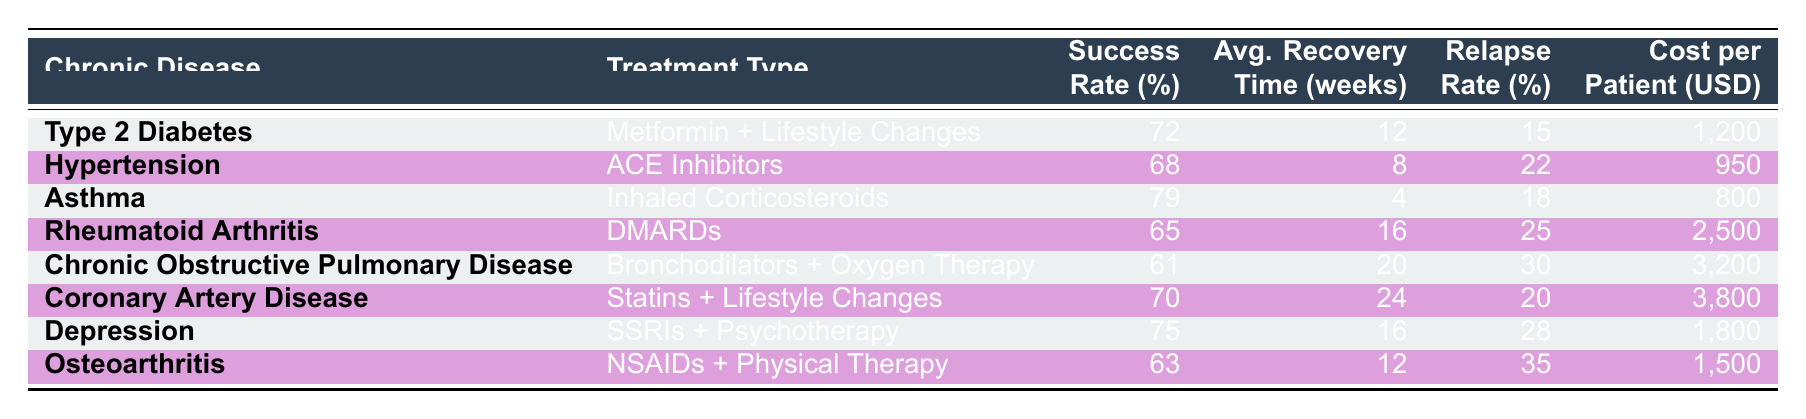What is the success rate for treating Asthma? According to the table, the success rate for treating Asthma with Inhaled Corticosteroids is listed directly as 79%.
Answer: 79% Which treatment has the highest relapse rate? The treatment with the highest relapse rate is Osteoarthritis, which has a relapse rate of 35%.
Answer: 35% What is the average recovery time for Chronic Obstructive Pulmonary Disease? The average recovery time for Chronic Obstructive Pulmonary Disease, treated with Bronchodilators and Oxygen Therapy, is 20 weeks.
Answer: 20 weeks Is the success rate for Type 2 Diabetes higher than that for Hypertension? Yes, the success rate for Type 2 Diabetes at 72% is higher than the success rate for Hypertension, which is 68%.
Answer: Yes What is the total cost per patient for treating both Depression and Osteoarthritis? To find the total cost, we add the cost for treating Depression at $1,800 and Osteoarthritis at $1,500: 1,800 + 1,500 = 3,300.
Answer: 3,300 What is the average success rate for all the treatments listed? To find the average success rate, sum all the success rates (72 + 68 + 79 + 65 + 61 + 70 + 75 + 63 = 563) and divide by the number of treatments (8). The average success rate is 563/8 = 70.375, which rounds to 70%.
Answer: 70.38% Does any treatment have a success rate below 65%? Yes, the treatment for Chronic Obstructive Pulmonary Disease has a success rate of 61%, which is below 65%.
Answer: Yes Which treatment option has the shortest average recovery time? The treatment with the shortest average recovery time is for Asthma, which has an average recovery time of 4 weeks.
Answer: 4 weeks 